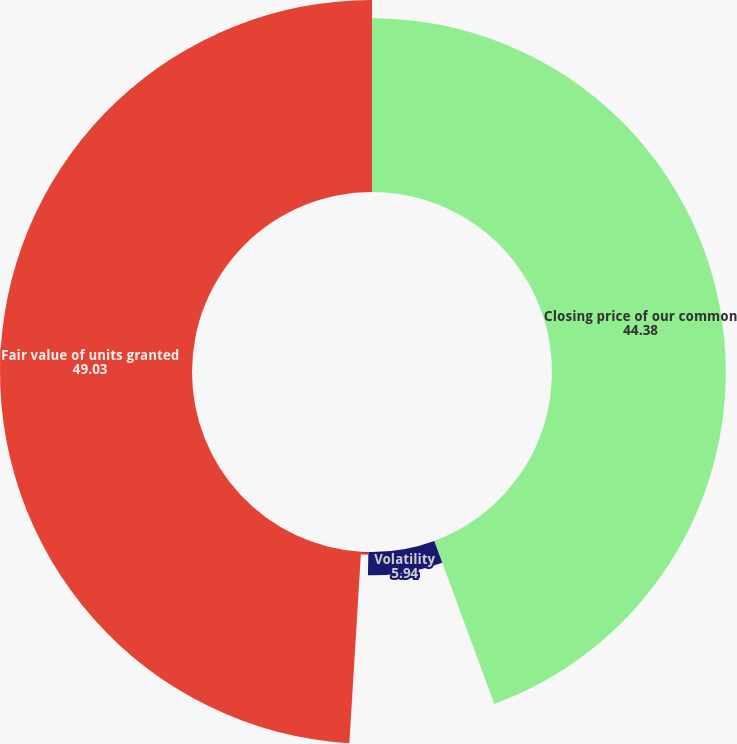Convert chart. <chart><loc_0><loc_0><loc_500><loc_500><pie_chart><fcel>Closing price of our common<fcel>Volatility<fcel>Risk-free interest rate<fcel>Fair value of units granted<nl><fcel>44.38%<fcel>5.94%<fcel>0.65%<fcel>49.03%<nl></chart> 